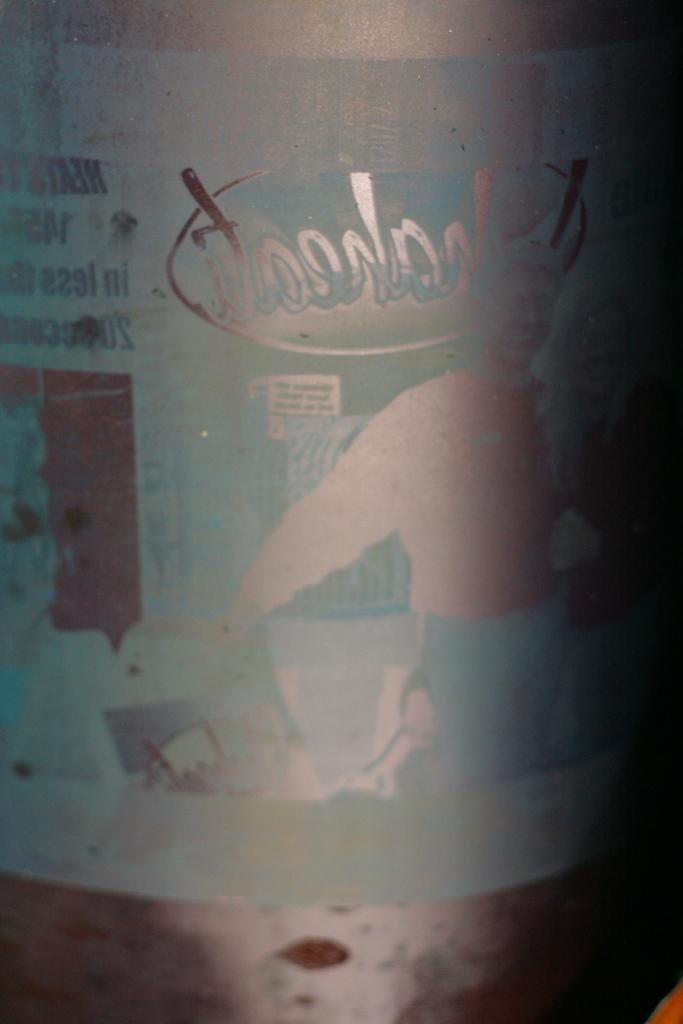Please provide a concise description of this image. In this image we can see the glass bottle and here we can see the reflection of few things in the glass bottle. 